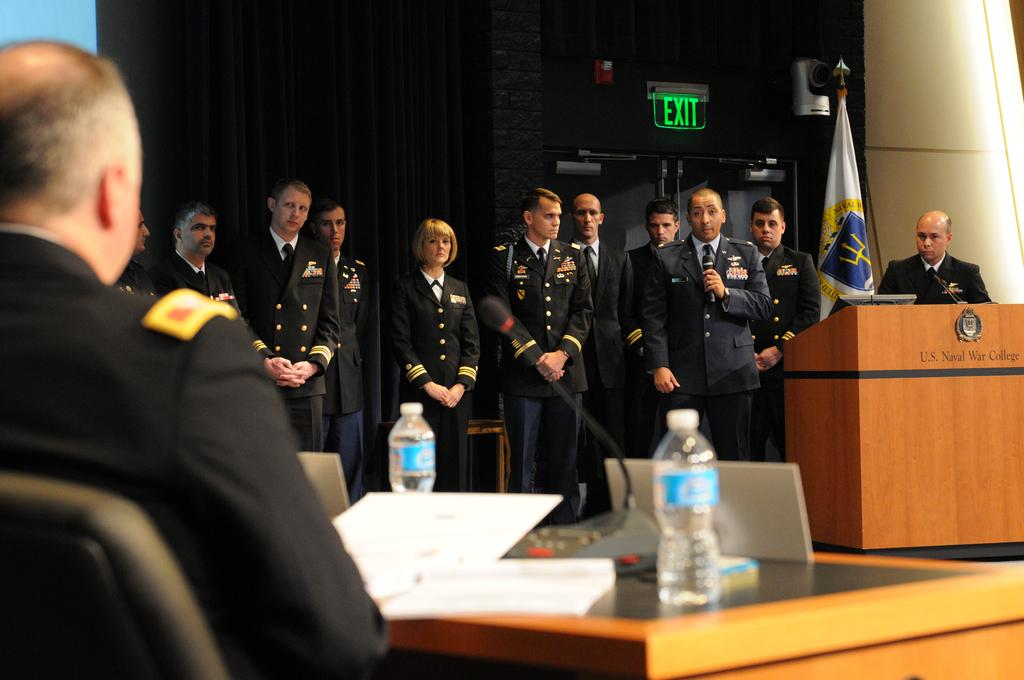What is the general setting of the image? There is a group of people standing in the image. Can you identify any specific roles or actions among the group? One person is holding a microphone. Are there any other notable individuals in the image? Yes, there is a man sitting in the left side of the image. What type of bird can be seen flying in the image? There is no bird present in the image; it features a group of people standing and one person holding a microphone. 